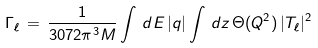<formula> <loc_0><loc_0><loc_500><loc_500>\Gamma _ { \ell } \, = \, \frac { 1 } { 3 0 7 2 \pi ^ { 3 } M } \int \, d E \, | { q } | \int \, d z \, \Theta ( Q ^ { 2 } ) \, | T _ { \ell } | ^ { 2 }</formula> 